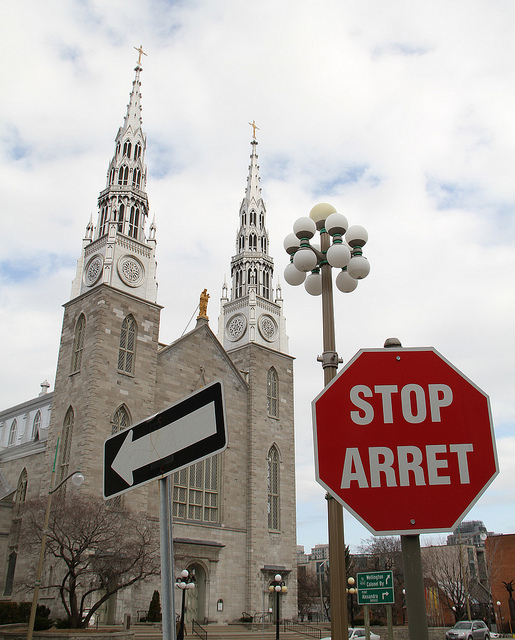Identify the text contained in this image. STOP ARRET 